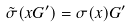Convert formula to latex. <formula><loc_0><loc_0><loc_500><loc_500>\tilde { \sigma } ( x G ^ { \prime } ) = \sigma ( x ) G ^ { \prime }</formula> 